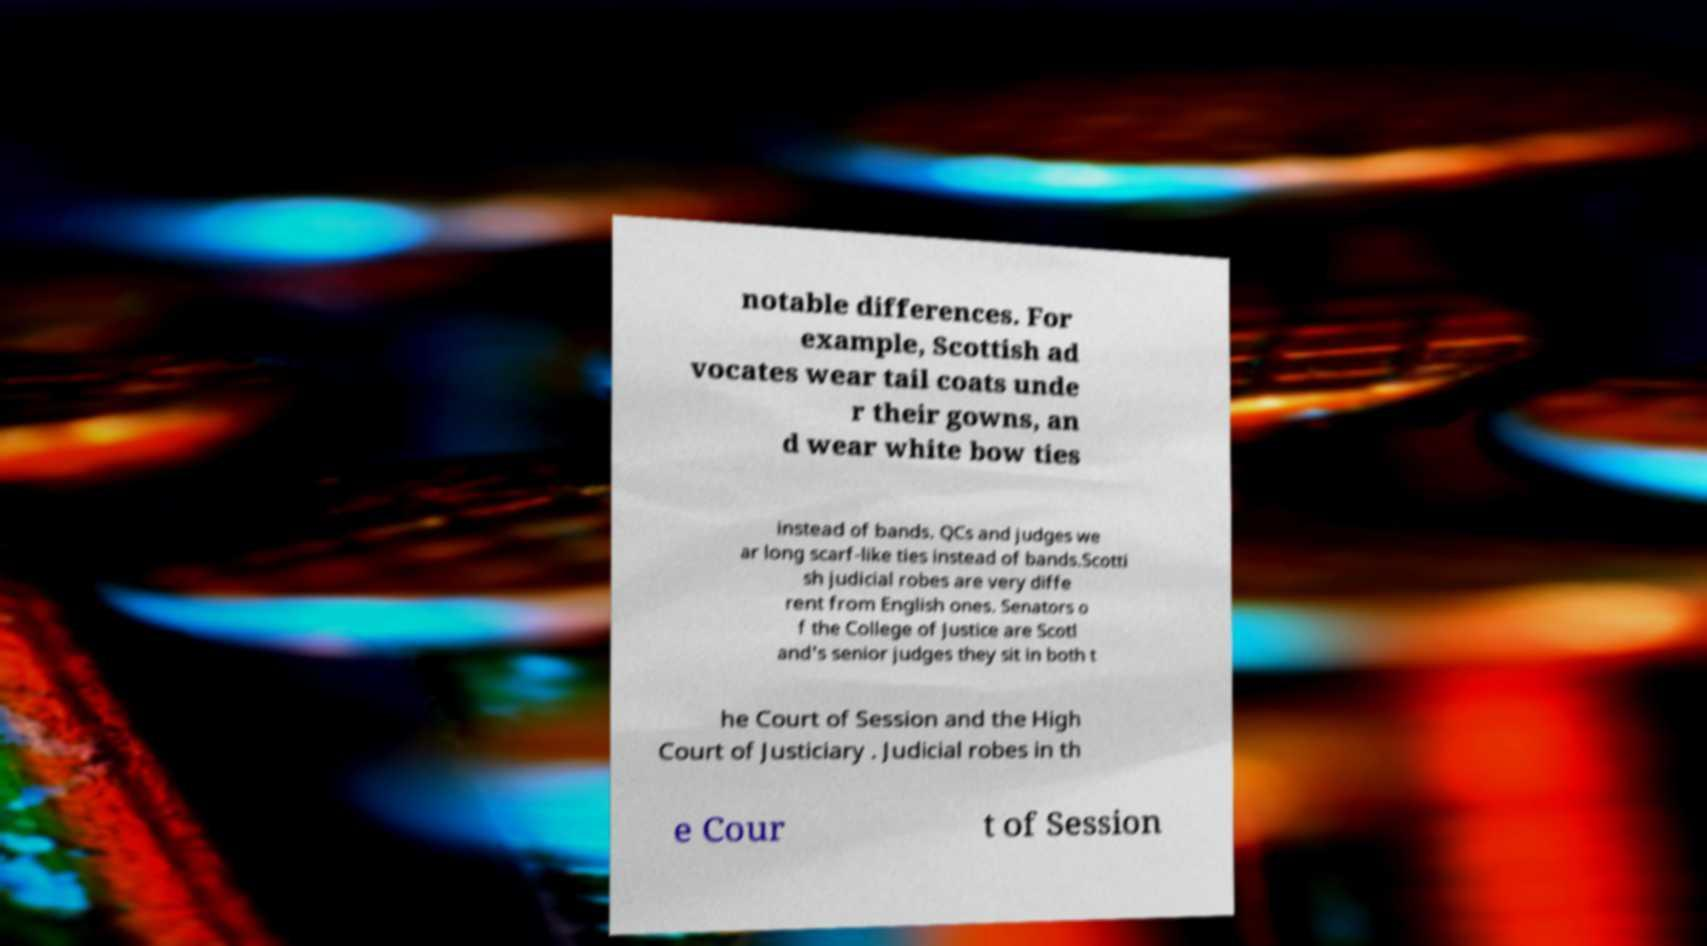There's text embedded in this image that I need extracted. Can you transcribe it verbatim? notable differences. For example, Scottish ad vocates wear tail coats unde r their gowns, an d wear white bow ties instead of bands. QCs and judges we ar long scarf-like ties instead of bands.Scotti sh judicial robes are very diffe rent from English ones. Senators o f the College of Justice are Scotl and's senior judges they sit in both t he Court of Session and the High Court of Justiciary . Judicial robes in th e Cour t of Session 